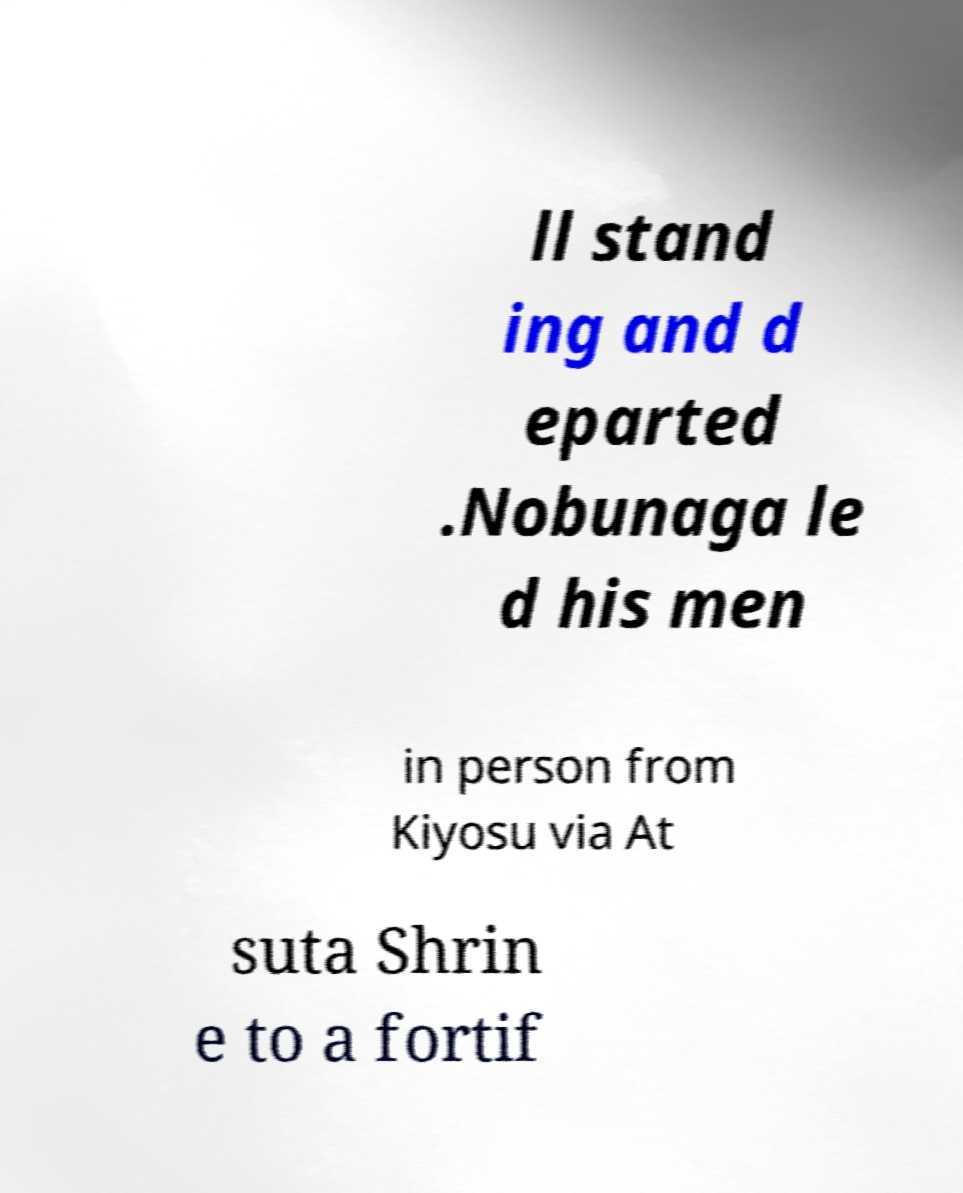Please read and relay the text visible in this image. What does it say? ll stand ing and d eparted .Nobunaga le d his men in person from Kiyosu via At suta Shrin e to a fortif 